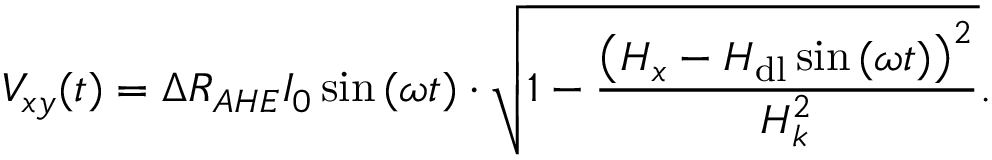Convert formula to latex. <formula><loc_0><loc_0><loc_500><loc_500>V _ { x y } ( t ) = \Delta R _ { A H E } I _ { 0 } \sin { ( \omega t ) } \cdot \sqrt { 1 - \frac { \left ( H _ { x } - H _ { d l } \sin { ( \omega t ) } \right ) ^ { 2 } } { H _ { k } ^ { 2 } } } .</formula> 